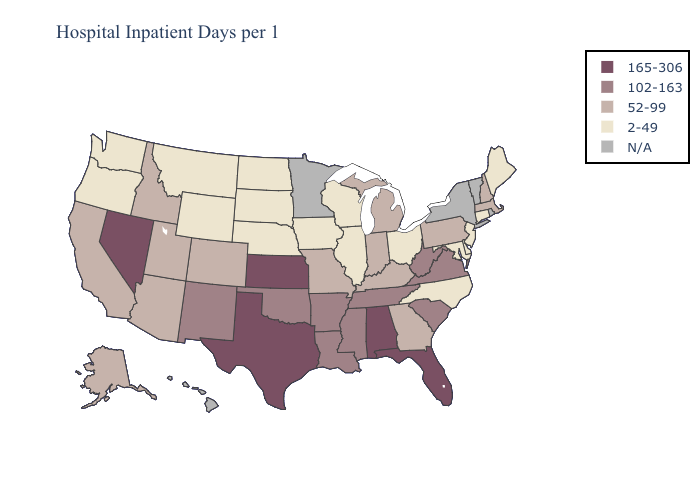Name the states that have a value in the range 102-163?
Answer briefly. Arkansas, Louisiana, Mississippi, New Mexico, Oklahoma, South Carolina, Tennessee, Virginia, West Virginia. What is the value of Iowa?
Concise answer only. 2-49. What is the highest value in the MidWest ?
Short answer required. 165-306. What is the highest value in the USA?
Be succinct. 165-306. What is the value of Kansas?
Short answer required. 165-306. Is the legend a continuous bar?
Answer briefly. No. What is the highest value in the West ?
Short answer required. 165-306. What is the lowest value in the USA?
Quick response, please. 2-49. How many symbols are there in the legend?
Quick response, please. 5. Name the states that have a value in the range 102-163?
Write a very short answer. Arkansas, Louisiana, Mississippi, New Mexico, Oklahoma, South Carolina, Tennessee, Virginia, West Virginia. What is the value of Wyoming?
Be succinct. 2-49. What is the lowest value in the USA?
Keep it brief. 2-49. Name the states that have a value in the range N/A?
Answer briefly. Hawaii, Minnesota, New York, Rhode Island, Vermont. What is the highest value in states that border South Carolina?
Concise answer only. 52-99. 